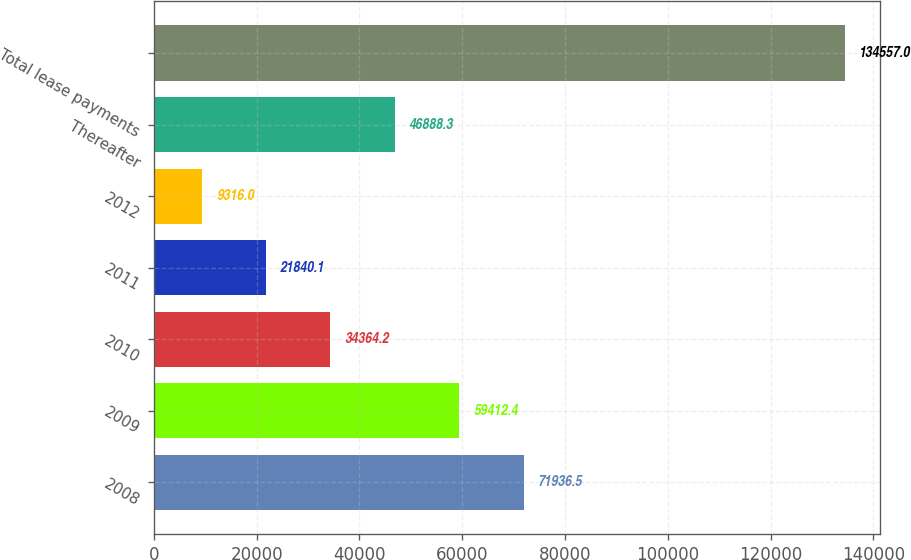Convert chart. <chart><loc_0><loc_0><loc_500><loc_500><bar_chart><fcel>2008<fcel>2009<fcel>2010<fcel>2011<fcel>2012<fcel>Thereafter<fcel>Total lease payments<nl><fcel>71936.5<fcel>59412.4<fcel>34364.2<fcel>21840.1<fcel>9316<fcel>46888.3<fcel>134557<nl></chart> 